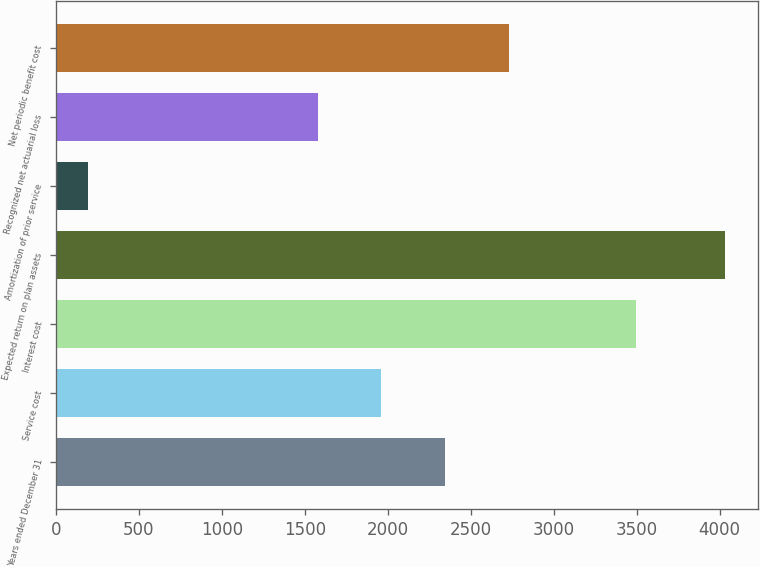Convert chart to OTSL. <chart><loc_0><loc_0><loc_500><loc_500><bar_chart><fcel>Years ended December 31<fcel>Service cost<fcel>Interest cost<fcel>Expected return on plan assets<fcel>Amortization of prior service<fcel>Recognized net actuarial loss<fcel>Net periodic benefit cost<nl><fcel>2344<fcel>1960.5<fcel>3494.5<fcel>4031<fcel>196<fcel>1577<fcel>2727.5<nl></chart> 